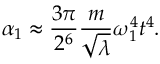<formula> <loc_0><loc_0><loc_500><loc_500>\alpha _ { 1 } \approx \frac { 3 \pi } { 2 ^ { 6 } } \frac { m } { \sqrt { \lambda } } \omega _ { 1 } ^ { 4 } t ^ { 4 } .</formula> 